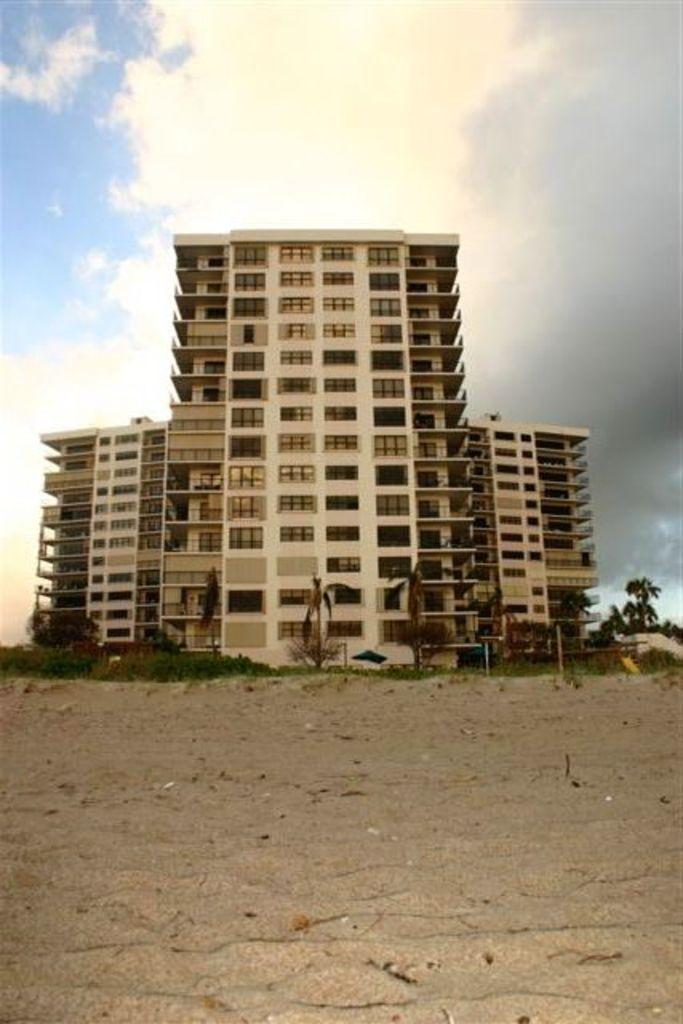What can be seen in the background of the image? There is a building in the background of the image. What is located in front of the building? There are plants in front of the building. How would you describe the sky in the image? The sky is cloudy in the image. How many lizards are playing with balls on the roof of the building in the image? There are no lizards or balls present in the image; it only features a building, plants, and a cloudy sky. 